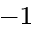<formula> <loc_0><loc_0><loc_500><loc_500>^ { - 1 }</formula> 